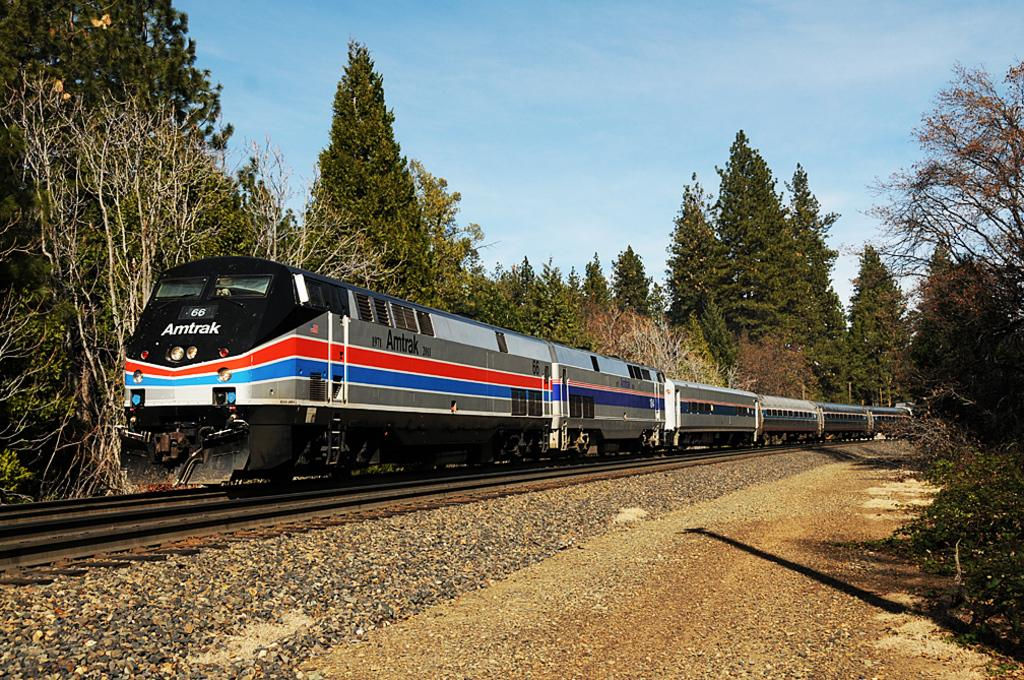What is the main subject of the image? There is a train in the image. Where is the train located? The train is on a rail track. What can be seen in the background of the image? There are trees in the background of the image. What is visible at the top of the image? The sky is visible at the top of the image. What type of terrain is present at the bottom of the image? Rocks are present on the land at the bottom of the image. What type of harmony is being protested by the fire in the image? There is no protest or fire present in the image; it features a train on a rail track with trees, sky, and rocks in the background. 